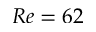<formula> <loc_0><loc_0><loc_500><loc_500>R e = 6 2</formula> 